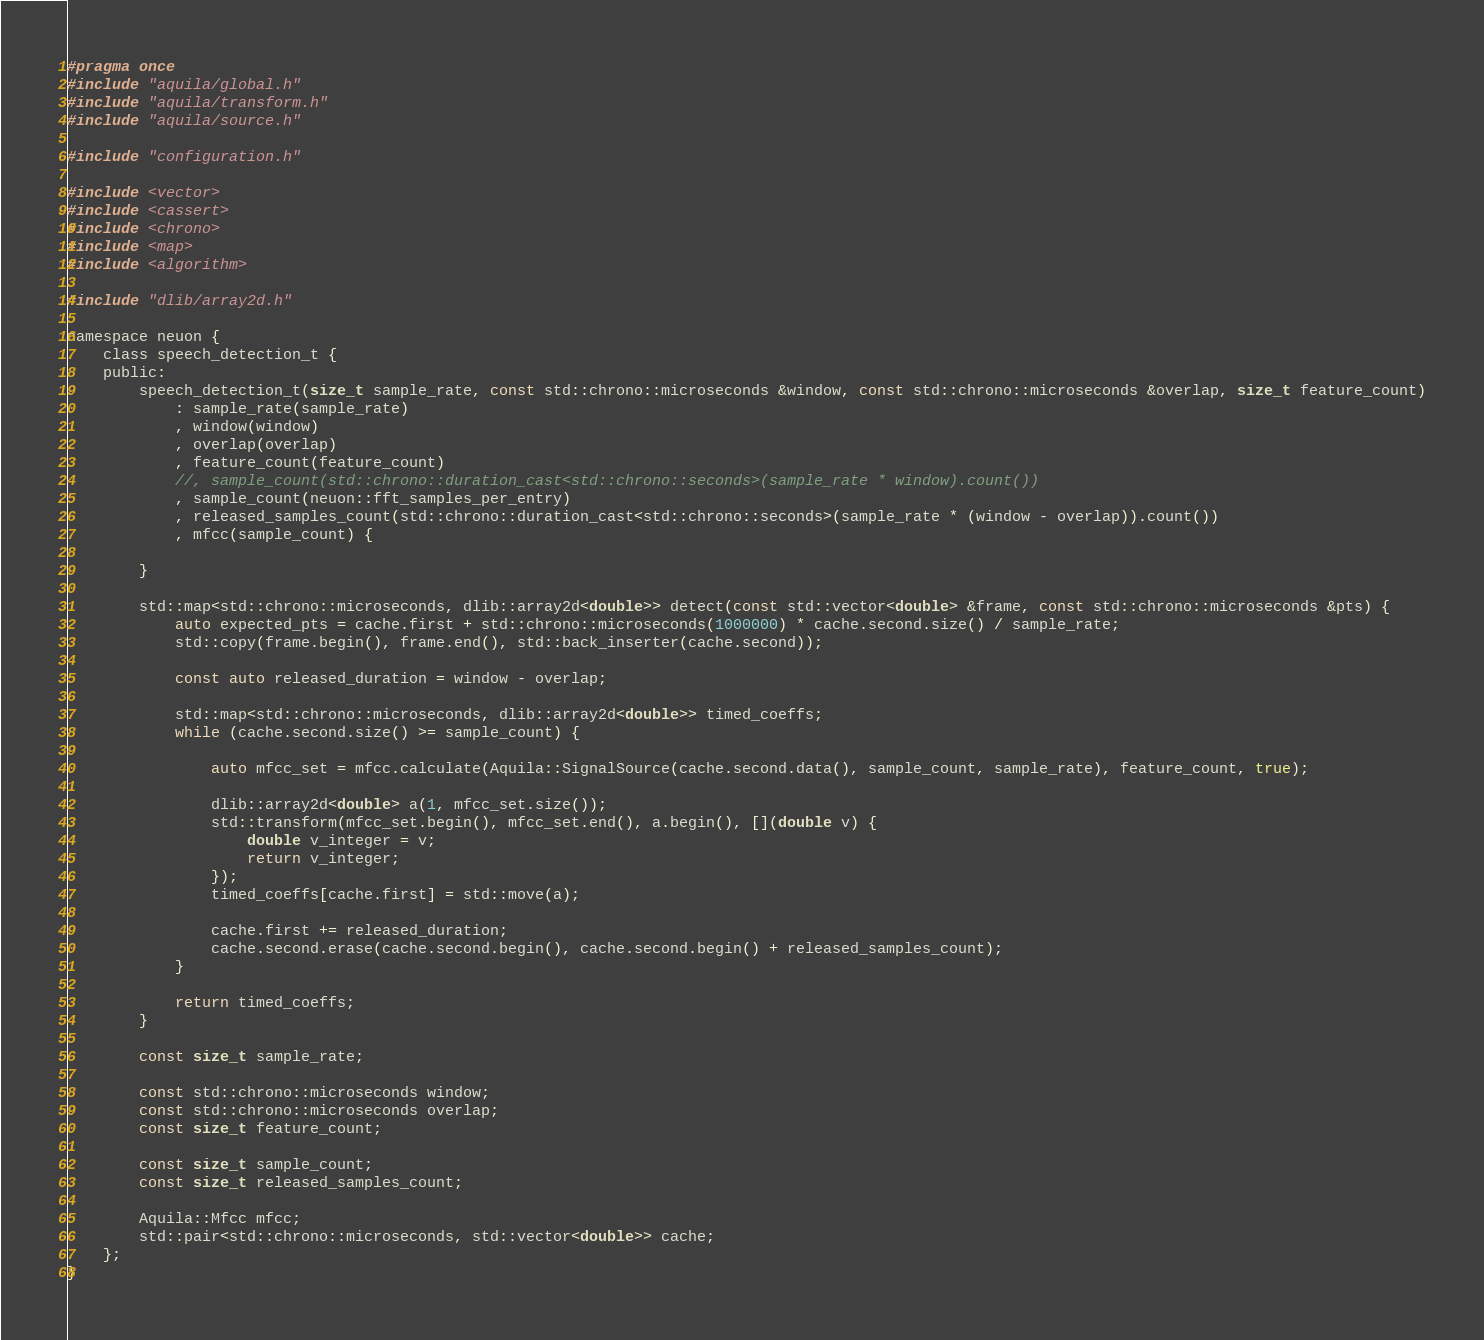<code> <loc_0><loc_0><loc_500><loc_500><_C_>#pragma once
#include "aquila/global.h"
#include "aquila/transform.h"
#include "aquila/source.h"

#include "configuration.h"

#include <vector>
#include <cassert>
#include <chrono>
#include <map>
#include <algorithm>

#include "dlib/array2d.h"

namespace neuon {
    class speech_detection_t {
    public:
        speech_detection_t(size_t sample_rate, const std::chrono::microseconds &window, const std::chrono::microseconds &overlap, size_t feature_count)
            : sample_rate(sample_rate)
            , window(window)
            , overlap(overlap)
            , feature_count(feature_count)
            //, sample_count(std::chrono::duration_cast<std::chrono::seconds>(sample_rate * window).count())
            , sample_count(neuon::fft_samples_per_entry)
            , released_samples_count(std::chrono::duration_cast<std::chrono::seconds>(sample_rate * (window - overlap)).count())
            , mfcc(sample_count) {

        }

        std::map<std::chrono::microseconds, dlib::array2d<double>> detect(const std::vector<double> &frame, const std::chrono::microseconds &pts) {
            auto expected_pts = cache.first + std::chrono::microseconds(1000000) * cache.second.size() / sample_rate;
            std::copy(frame.begin(), frame.end(), std::back_inserter(cache.second));

            const auto released_duration = window - overlap;

            std::map<std::chrono::microseconds, dlib::array2d<double>> timed_coeffs;
            while (cache.second.size() >= sample_count) {

                auto mfcc_set = mfcc.calculate(Aquila::SignalSource(cache.second.data(), sample_count, sample_rate), feature_count, true);

                dlib::array2d<double> a(1, mfcc_set.size());
                std::transform(mfcc_set.begin(), mfcc_set.end(), a.begin(), [](double v) {
                    double v_integer = v;
                    return v_integer;
                });
                timed_coeffs[cache.first] = std::move(a);

                cache.first += released_duration;
                cache.second.erase(cache.second.begin(), cache.second.begin() + released_samples_count);
            }

            return timed_coeffs;
        }

        const size_t sample_rate;

        const std::chrono::microseconds window;
        const std::chrono::microseconds overlap;
        const size_t feature_count;

        const size_t sample_count;
        const size_t released_samples_count;

        Aquila::Mfcc mfcc;
        std::pair<std::chrono::microseconds, std::vector<double>> cache;
    };
}
</code> 